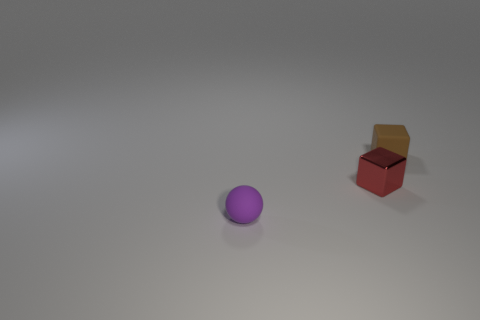Are there an equal number of objects that are on the right side of the purple rubber ball and small green cylinders?
Offer a terse response. No. Are the small object that is in front of the metallic block and the tiny block that is in front of the brown rubber object made of the same material?
Provide a short and direct response. No. Is there any other thing that is made of the same material as the tiny brown block?
Give a very brief answer. Yes. There is a small thing behind the small red metal thing; is its shape the same as the thing that is to the left of the small red shiny block?
Ensure brevity in your answer.  No. Are there fewer balls behind the tiny red shiny cube than tiny things?
Give a very brief answer. Yes. How many small matte objects have the same color as the rubber cube?
Offer a terse response. 0. What size is the thing that is in front of the red cube?
Provide a succinct answer. Small. What is the shape of the matte object in front of the cube to the left of the rubber object behind the small purple rubber object?
Your response must be concise. Sphere. The tiny thing that is both in front of the brown rubber object and right of the tiny ball has what shape?
Keep it short and to the point. Cube. Is there another brown thing of the same size as the brown matte object?
Ensure brevity in your answer.  No. 